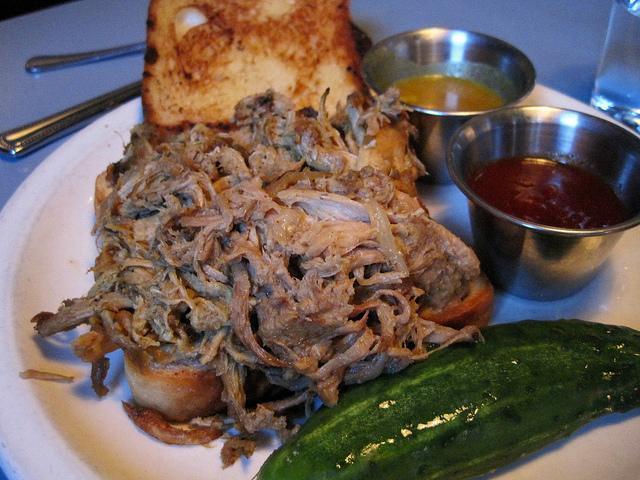How many bowls are there?
Give a very brief answer. 2. How many people are using backpacks or bags?
Give a very brief answer. 0. 